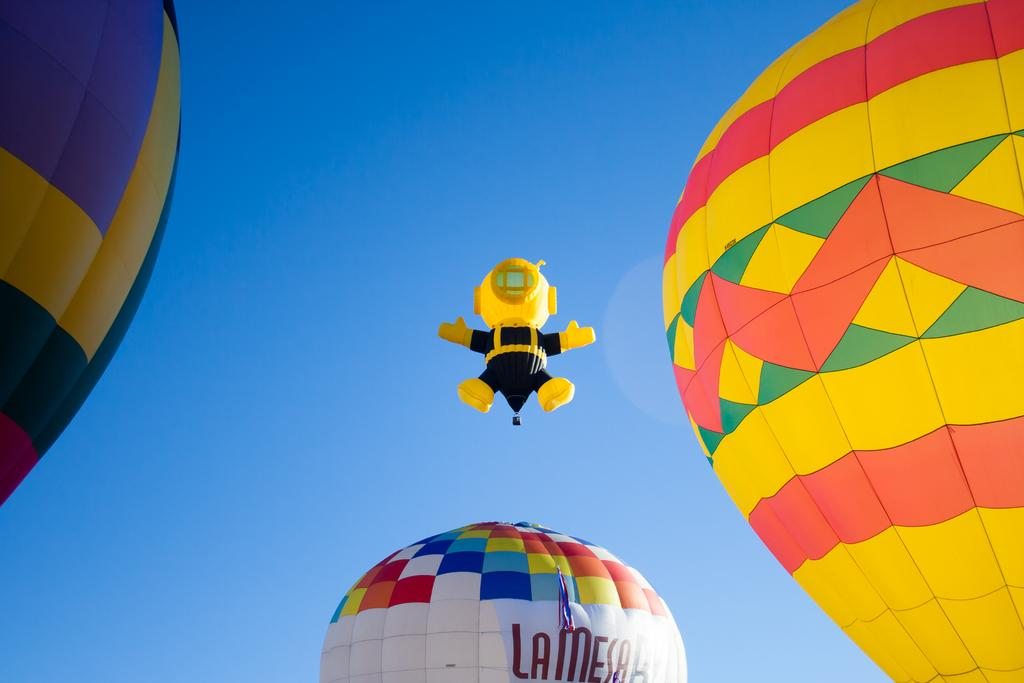Provide a one-sentence caption for the provided image. A series of hot air balloons in the sky, one of which is advertising La Mesa. 